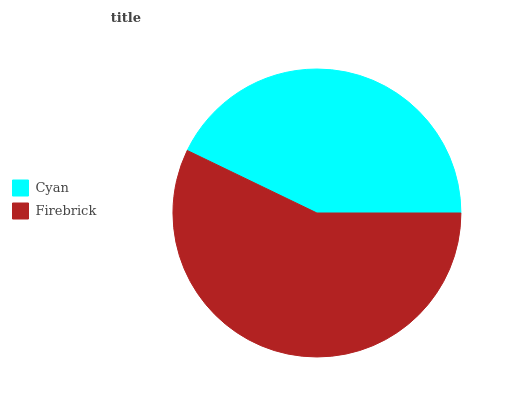Is Cyan the minimum?
Answer yes or no. Yes. Is Firebrick the maximum?
Answer yes or no. Yes. Is Firebrick the minimum?
Answer yes or no. No. Is Firebrick greater than Cyan?
Answer yes or no. Yes. Is Cyan less than Firebrick?
Answer yes or no. Yes. Is Cyan greater than Firebrick?
Answer yes or no. No. Is Firebrick less than Cyan?
Answer yes or no. No. Is Firebrick the high median?
Answer yes or no. Yes. Is Cyan the low median?
Answer yes or no. Yes. Is Cyan the high median?
Answer yes or no. No. Is Firebrick the low median?
Answer yes or no. No. 